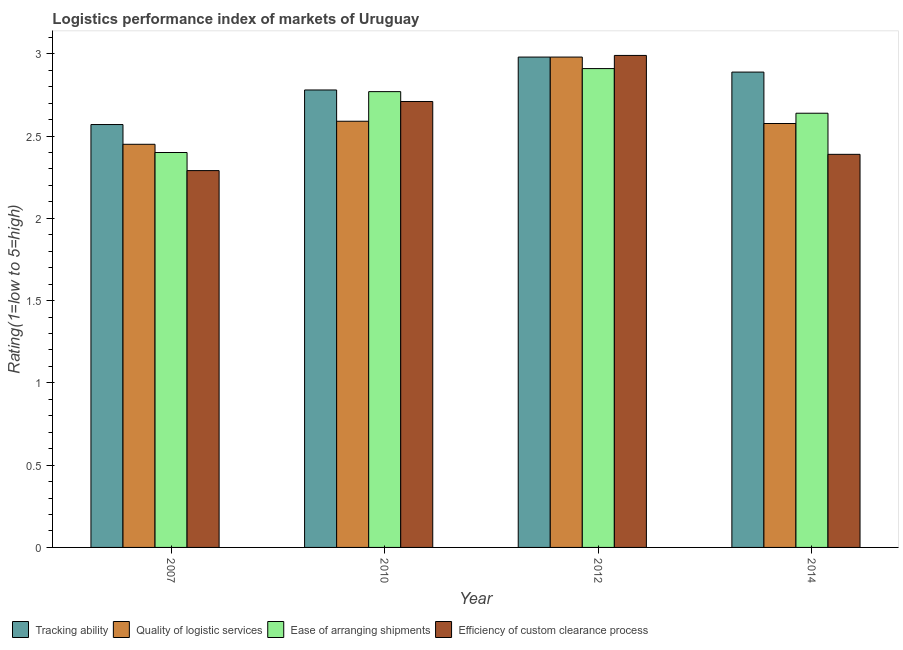How many different coloured bars are there?
Your answer should be compact. 4. How many groups of bars are there?
Ensure brevity in your answer.  4. Are the number of bars on each tick of the X-axis equal?
Your response must be concise. Yes. How many bars are there on the 4th tick from the left?
Your answer should be very brief. 4. How many bars are there on the 1st tick from the right?
Make the answer very short. 4. What is the lpi rating of ease of arranging shipments in 2014?
Offer a very short reply. 2.64. Across all years, what is the maximum lpi rating of efficiency of custom clearance process?
Give a very brief answer. 2.99. Across all years, what is the minimum lpi rating of tracking ability?
Make the answer very short. 2.57. What is the total lpi rating of efficiency of custom clearance process in the graph?
Provide a succinct answer. 10.38. What is the difference between the lpi rating of tracking ability in 2012 and that in 2014?
Provide a short and direct response. 0.09. What is the difference between the lpi rating of tracking ability in 2014 and the lpi rating of quality of logistic services in 2010?
Keep it short and to the point. 0.11. What is the average lpi rating of tracking ability per year?
Your response must be concise. 2.8. In how many years, is the lpi rating of efficiency of custom clearance process greater than 1.3?
Offer a very short reply. 4. What is the ratio of the lpi rating of ease of arranging shipments in 2010 to that in 2012?
Your answer should be very brief. 0.95. Is the lpi rating of efficiency of custom clearance process in 2007 less than that in 2012?
Give a very brief answer. Yes. Is the difference between the lpi rating of ease of arranging shipments in 2007 and 2010 greater than the difference between the lpi rating of quality of logistic services in 2007 and 2010?
Offer a very short reply. No. What is the difference between the highest and the second highest lpi rating of ease of arranging shipments?
Give a very brief answer. 0.14. What is the difference between the highest and the lowest lpi rating of quality of logistic services?
Keep it short and to the point. 0.53. In how many years, is the lpi rating of tracking ability greater than the average lpi rating of tracking ability taken over all years?
Provide a short and direct response. 2. What does the 2nd bar from the left in 2012 represents?
Provide a short and direct response. Quality of logistic services. What does the 2nd bar from the right in 2012 represents?
Offer a very short reply. Ease of arranging shipments. How many bars are there?
Your answer should be compact. 16. What is the difference between two consecutive major ticks on the Y-axis?
Your answer should be compact. 0.5. Are the values on the major ticks of Y-axis written in scientific E-notation?
Provide a short and direct response. No. Does the graph contain grids?
Ensure brevity in your answer.  No. How are the legend labels stacked?
Offer a terse response. Horizontal. What is the title of the graph?
Make the answer very short. Logistics performance index of markets of Uruguay. Does "European Union" appear as one of the legend labels in the graph?
Offer a very short reply. No. What is the label or title of the Y-axis?
Provide a short and direct response. Rating(1=low to 5=high). What is the Rating(1=low to 5=high) in Tracking ability in 2007?
Ensure brevity in your answer.  2.57. What is the Rating(1=low to 5=high) of Quality of logistic services in 2007?
Your answer should be compact. 2.45. What is the Rating(1=low to 5=high) in Ease of arranging shipments in 2007?
Your answer should be compact. 2.4. What is the Rating(1=low to 5=high) in Efficiency of custom clearance process in 2007?
Give a very brief answer. 2.29. What is the Rating(1=low to 5=high) in Tracking ability in 2010?
Give a very brief answer. 2.78. What is the Rating(1=low to 5=high) of Quality of logistic services in 2010?
Provide a short and direct response. 2.59. What is the Rating(1=low to 5=high) in Ease of arranging shipments in 2010?
Keep it short and to the point. 2.77. What is the Rating(1=low to 5=high) in Efficiency of custom clearance process in 2010?
Keep it short and to the point. 2.71. What is the Rating(1=low to 5=high) in Tracking ability in 2012?
Keep it short and to the point. 2.98. What is the Rating(1=low to 5=high) in Quality of logistic services in 2012?
Keep it short and to the point. 2.98. What is the Rating(1=low to 5=high) in Ease of arranging shipments in 2012?
Give a very brief answer. 2.91. What is the Rating(1=low to 5=high) in Efficiency of custom clearance process in 2012?
Give a very brief answer. 2.99. What is the Rating(1=low to 5=high) of Tracking ability in 2014?
Provide a short and direct response. 2.89. What is the Rating(1=low to 5=high) in Quality of logistic services in 2014?
Keep it short and to the point. 2.58. What is the Rating(1=low to 5=high) of Ease of arranging shipments in 2014?
Provide a short and direct response. 2.64. What is the Rating(1=low to 5=high) of Efficiency of custom clearance process in 2014?
Your answer should be compact. 2.39. Across all years, what is the maximum Rating(1=low to 5=high) in Tracking ability?
Your answer should be compact. 2.98. Across all years, what is the maximum Rating(1=low to 5=high) of Quality of logistic services?
Your response must be concise. 2.98. Across all years, what is the maximum Rating(1=low to 5=high) of Ease of arranging shipments?
Offer a very short reply. 2.91. Across all years, what is the maximum Rating(1=low to 5=high) of Efficiency of custom clearance process?
Your answer should be compact. 2.99. Across all years, what is the minimum Rating(1=low to 5=high) in Tracking ability?
Your answer should be very brief. 2.57. Across all years, what is the minimum Rating(1=low to 5=high) in Quality of logistic services?
Your answer should be compact. 2.45. Across all years, what is the minimum Rating(1=low to 5=high) in Efficiency of custom clearance process?
Provide a succinct answer. 2.29. What is the total Rating(1=low to 5=high) of Tracking ability in the graph?
Offer a very short reply. 11.22. What is the total Rating(1=low to 5=high) in Quality of logistic services in the graph?
Ensure brevity in your answer.  10.6. What is the total Rating(1=low to 5=high) in Ease of arranging shipments in the graph?
Offer a terse response. 10.72. What is the total Rating(1=low to 5=high) in Efficiency of custom clearance process in the graph?
Provide a short and direct response. 10.38. What is the difference between the Rating(1=low to 5=high) of Tracking ability in 2007 and that in 2010?
Your response must be concise. -0.21. What is the difference between the Rating(1=low to 5=high) in Quality of logistic services in 2007 and that in 2010?
Make the answer very short. -0.14. What is the difference between the Rating(1=low to 5=high) in Ease of arranging shipments in 2007 and that in 2010?
Offer a very short reply. -0.37. What is the difference between the Rating(1=low to 5=high) of Efficiency of custom clearance process in 2007 and that in 2010?
Your response must be concise. -0.42. What is the difference between the Rating(1=low to 5=high) in Tracking ability in 2007 and that in 2012?
Give a very brief answer. -0.41. What is the difference between the Rating(1=low to 5=high) of Quality of logistic services in 2007 and that in 2012?
Your answer should be very brief. -0.53. What is the difference between the Rating(1=low to 5=high) in Ease of arranging shipments in 2007 and that in 2012?
Your answer should be very brief. -0.51. What is the difference between the Rating(1=low to 5=high) in Efficiency of custom clearance process in 2007 and that in 2012?
Provide a short and direct response. -0.7. What is the difference between the Rating(1=low to 5=high) in Tracking ability in 2007 and that in 2014?
Your answer should be very brief. -0.32. What is the difference between the Rating(1=low to 5=high) in Quality of logistic services in 2007 and that in 2014?
Keep it short and to the point. -0.13. What is the difference between the Rating(1=low to 5=high) in Ease of arranging shipments in 2007 and that in 2014?
Give a very brief answer. -0.24. What is the difference between the Rating(1=low to 5=high) in Efficiency of custom clearance process in 2007 and that in 2014?
Your answer should be very brief. -0.1. What is the difference between the Rating(1=low to 5=high) of Quality of logistic services in 2010 and that in 2012?
Offer a terse response. -0.39. What is the difference between the Rating(1=low to 5=high) in Ease of arranging shipments in 2010 and that in 2012?
Keep it short and to the point. -0.14. What is the difference between the Rating(1=low to 5=high) in Efficiency of custom clearance process in 2010 and that in 2012?
Provide a succinct answer. -0.28. What is the difference between the Rating(1=low to 5=high) in Tracking ability in 2010 and that in 2014?
Ensure brevity in your answer.  -0.11. What is the difference between the Rating(1=low to 5=high) of Quality of logistic services in 2010 and that in 2014?
Make the answer very short. 0.01. What is the difference between the Rating(1=low to 5=high) in Ease of arranging shipments in 2010 and that in 2014?
Give a very brief answer. 0.13. What is the difference between the Rating(1=low to 5=high) in Efficiency of custom clearance process in 2010 and that in 2014?
Offer a terse response. 0.32. What is the difference between the Rating(1=low to 5=high) in Tracking ability in 2012 and that in 2014?
Provide a short and direct response. 0.09. What is the difference between the Rating(1=low to 5=high) in Quality of logistic services in 2012 and that in 2014?
Make the answer very short. 0.4. What is the difference between the Rating(1=low to 5=high) of Ease of arranging shipments in 2012 and that in 2014?
Ensure brevity in your answer.  0.27. What is the difference between the Rating(1=low to 5=high) in Efficiency of custom clearance process in 2012 and that in 2014?
Provide a succinct answer. 0.6. What is the difference between the Rating(1=low to 5=high) in Tracking ability in 2007 and the Rating(1=low to 5=high) in Quality of logistic services in 2010?
Keep it short and to the point. -0.02. What is the difference between the Rating(1=low to 5=high) of Tracking ability in 2007 and the Rating(1=low to 5=high) of Efficiency of custom clearance process in 2010?
Ensure brevity in your answer.  -0.14. What is the difference between the Rating(1=low to 5=high) of Quality of logistic services in 2007 and the Rating(1=low to 5=high) of Ease of arranging shipments in 2010?
Provide a short and direct response. -0.32. What is the difference between the Rating(1=low to 5=high) in Quality of logistic services in 2007 and the Rating(1=low to 5=high) in Efficiency of custom clearance process in 2010?
Ensure brevity in your answer.  -0.26. What is the difference between the Rating(1=low to 5=high) in Ease of arranging shipments in 2007 and the Rating(1=low to 5=high) in Efficiency of custom clearance process in 2010?
Ensure brevity in your answer.  -0.31. What is the difference between the Rating(1=low to 5=high) of Tracking ability in 2007 and the Rating(1=low to 5=high) of Quality of logistic services in 2012?
Provide a succinct answer. -0.41. What is the difference between the Rating(1=low to 5=high) of Tracking ability in 2007 and the Rating(1=low to 5=high) of Ease of arranging shipments in 2012?
Keep it short and to the point. -0.34. What is the difference between the Rating(1=low to 5=high) in Tracking ability in 2007 and the Rating(1=low to 5=high) in Efficiency of custom clearance process in 2012?
Offer a very short reply. -0.42. What is the difference between the Rating(1=low to 5=high) of Quality of logistic services in 2007 and the Rating(1=low to 5=high) of Ease of arranging shipments in 2012?
Ensure brevity in your answer.  -0.46. What is the difference between the Rating(1=low to 5=high) in Quality of logistic services in 2007 and the Rating(1=low to 5=high) in Efficiency of custom clearance process in 2012?
Your answer should be very brief. -0.54. What is the difference between the Rating(1=low to 5=high) in Ease of arranging shipments in 2007 and the Rating(1=low to 5=high) in Efficiency of custom clearance process in 2012?
Your response must be concise. -0.59. What is the difference between the Rating(1=low to 5=high) in Tracking ability in 2007 and the Rating(1=low to 5=high) in Quality of logistic services in 2014?
Offer a very short reply. -0.01. What is the difference between the Rating(1=low to 5=high) in Tracking ability in 2007 and the Rating(1=low to 5=high) in Ease of arranging shipments in 2014?
Keep it short and to the point. -0.07. What is the difference between the Rating(1=low to 5=high) in Tracking ability in 2007 and the Rating(1=low to 5=high) in Efficiency of custom clearance process in 2014?
Your answer should be very brief. 0.18. What is the difference between the Rating(1=low to 5=high) of Quality of logistic services in 2007 and the Rating(1=low to 5=high) of Ease of arranging shipments in 2014?
Ensure brevity in your answer.  -0.19. What is the difference between the Rating(1=low to 5=high) in Quality of logistic services in 2007 and the Rating(1=low to 5=high) in Efficiency of custom clearance process in 2014?
Your answer should be compact. 0.06. What is the difference between the Rating(1=low to 5=high) of Ease of arranging shipments in 2007 and the Rating(1=low to 5=high) of Efficiency of custom clearance process in 2014?
Your answer should be compact. 0.01. What is the difference between the Rating(1=low to 5=high) in Tracking ability in 2010 and the Rating(1=low to 5=high) in Ease of arranging shipments in 2012?
Your response must be concise. -0.13. What is the difference between the Rating(1=low to 5=high) in Tracking ability in 2010 and the Rating(1=low to 5=high) in Efficiency of custom clearance process in 2012?
Your answer should be compact. -0.21. What is the difference between the Rating(1=low to 5=high) of Quality of logistic services in 2010 and the Rating(1=low to 5=high) of Ease of arranging shipments in 2012?
Your answer should be very brief. -0.32. What is the difference between the Rating(1=low to 5=high) in Quality of logistic services in 2010 and the Rating(1=low to 5=high) in Efficiency of custom clearance process in 2012?
Provide a short and direct response. -0.4. What is the difference between the Rating(1=low to 5=high) of Ease of arranging shipments in 2010 and the Rating(1=low to 5=high) of Efficiency of custom clearance process in 2012?
Offer a very short reply. -0.22. What is the difference between the Rating(1=low to 5=high) in Tracking ability in 2010 and the Rating(1=low to 5=high) in Quality of logistic services in 2014?
Provide a succinct answer. 0.2. What is the difference between the Rating(1=low to 5=high) in Tracking ability in 2010 and the Rating(1=low to 5=high) in Ease of arranging shipments in 2014?
Offer a terse response. 0.14. What is the difference between the Rating(1=low to 5=high) in Tracking ability in 2010 and the Rating(1=low to 5=high) in Efficiency of custom clearance process in 2014?
Your answer should be compact. 0.39. What is the difference between the Rating(1=low to 5=high) of Quality of logistic services in 2010 and the Rating(1=low to 5=high) of Ease of arranging shipments in 2014?
Ensure brevity in your answer.  -0.05. What is the difference between the Rating(1=low to 5=high) in Quality of logistic services in 2010 and the Rating(1=low to 5=high) in Efficiency of custom clearance process in 2014?
Your answer should be compact. 0.2. What is the difference between the Rating(1=low to 5=high) in Ease of arranging shipments in 2010 and the Rating(1=low to 5=high) in Efficiency of custom clearance process in 2014?
Ensure brevity in your answer.  0.38. What is the difference between the Rating(1=low to 5=high) in Tracking ability in 2012 and the Rating(1=low to 5=high) in Quality of logistic services in 2014?
Make the answer very short. 0.4. What is the difference between the Rating(1=low to 5=high) in Tracking ability in 2012 and the Rating(1=low to 5=high) in Ease of arranging shipments in 2014?
Give a very brief answer. 0.34. What is the difference between the Rating(1=low to 5=high) in Tracking ability in 2012 and the Rating(1=low to 5=high) in Efficiency of custom clearance process in 2014?
Provide a short and direct response. 0.59. What is the difference between the Rating(1=low to 5=high) in Quality of logistic services in 2012 and the Rating(1=low to 5=high) in Ease of arranging shipments in 2014?
Your response must be concise. 0.34. What is the difference between the Rating(1=low to 5=high) in Quality of logistic services in 2012 and the Rating(1=low to 5=high) in Efficiency of custom clearance process in 2014?
Provide a short and direct response. 0.59. What is the difference between the Rating(1=low to 5=high) in Ease of arranging shipments in 2012 and the Rating(1=low to 5=high) in Efficiency of custom clearance process in 2014?
Keep it short and to the point. 0.52. What is the average Rating(1=low to 5=high) in Tracking ability per year?
Provide a succinct answer. 2.8. What is the average Rating(1=low to 5=high) of Quality of logistic services per year?
Provide a short and direct response. 2.65. What is the average Rating(1=low to 5=high) in Ease of arranging shipments per year?
Your answer should be very brief. 2.68. What is the average Rating(1=low to 5=high) in Efficiency of custom clearance process per year?
Your answer should be compact. 2.59. In the year 2007, what is the difference between the Rating(1=low to 5=high) in Tracking ability and Rating(1=low to 5=high) in Quality of logistic services?
Provide a succinct answer. 0.12. In the year 2007, what is the difference between the Rating(1=low to 5=high) of Tracking ability and Rating(1=low to 5=high) of Ease of arranging shipments?
Offer a very short reply. 0.17. In the year 2007, what is the difference between the Rating(1=low to 5=high) of Tracking ability and Rating(1=low to 5=high) of Efficiency of custom clearance process?
Your response must be concise. 0.28. In the year 2007, what is the difference between the Rating(1=low to 5=high) in Quality of logistic services and Rating(1=low to 5=high) in Ease of arranging shipments?
Keep it short and to the point. 0.05. In the year 2007, what is the difference between the Rating(1=low to 5=high) of Quality of logistic services and Rating(1=low to 5=high) of Efficiency of custom clearance process?
Make the answer very short. 0.16. In the year 2007, what is the difference between the Rating(1=low to 5=high) of Ease of arranging shipments and Rating(1=low to 5=high) of Efficiency of custom clearance process?
Your answer should be compact. 0.11. In the year 2010, what is the difference between the Rating(1=low to 5=high) of Tracking ability and Rating(1=low to 5=high) of Quality of logistic services?
Keep it short and to the point. 0.19. In the year 2010, what is the difference between the Rating(1=low to 5=high) of Tracking ability and Rating(1=low to 5=high) of Ease of arranging shipments?
Provide a succinct answer. 0.01. In the year 2010, what is the difference between the Rating(1=low to 5=high) in Tracking ability and Rating(1=low to 5=high) in Efficiency of custom clearance process?
Offer a terse response. 0.07. In the year 2010, what is the difference between the Rating(1=low to 5=high) of Quality of logistic services and Rating(1=low to 5=high) of Ease of arranging shipments?
Offer a very short reply. -0.18. In the year 2010, what is the difference between the Rating(1=low to 5=high) of Quality of logistic services and Rating(1=low to 5=high) of Efficiency of custom clearance process?
Offer a very short reply. -0.12. In the year 2012, what is the difference between the Rating(1=low to 5=high) in Tracking ability and Rating(1=low to 5=high) in Ease of arranging shipments?
Give a very brief answer. 0.07. In the year 2012, what is the difference between the Rating(1=low to 5=high) in Tracking ability and Rating(1=low to 5=high) in Efficiency of custom clearance process?
Your answer should be very brief. -0.01. In the year 2012, what is the difference between the Rating(1=low to 5=high) of Quality of logistic services and Rating(1=low to 5=high) of Ease of arranging shipments?
Make the answer very short. 0.07. In the year 2012, what is the difference between the Rating(1=low to 5=high) in Quality of logistic services and Rating(1=low to 5=high) in Efficiency of custom clearance process?
Keep it short and to the point. -0.01. In the year 2012, what is the difference between the Rating(1=low to 5=high) in Ease of arranging shipments and Rating(1=low to 5=high) in Efficiency of custom clearance process?
Ensure brevity in your answer.  -0.08. In the year 2014, what is the difference between the Rating(1=low to 5=high) in Tracking ability and Rating(1=low to 5=high) in Quality of logistic services?
Ensure brevity in your answer.  0.31. In the year 2014, what is the difference between the Rating(1=low to 5=high) of Tracking ability and Rating(1=low to 5=high) of Efficiency of custom clearance process?
Provide a succinct answer. 0.5. In the year 2014, what is the difference between the Rating(1=low to 5=high) of Quality of logistic services and Rating(1=low to 5=high) of Ease of arranging shipments?
Give a very brief answer. -0.06. In the year 2014, what is the difference between the Rating(1=low to 5=high) in Quality of logistic services and Rating(1=low to 5=high) in Efficiency of custom clearance process?
Ensure brevity in your answer.  0.19. In the year 2014, what is the difference between the Rating(1=low to 5=high) of Ease of arranging shipments and Rating(1=low to 5=high) of Efficiency of custom clearance process?
Your answer should be compact. 0.25. What is the ratio of the Rating(1=low to 5=high) of Tracking ability in 2007 to that in 2010?
Keep it short and to the point. 0.92. What is the ratio of the Rating(1=low to 5=high) in Quality of logistic services in 2007 to that in 2010?
Offer a terse response. 0.95. What is the ratio of the Rating(1=low to 5=high) in Ease of arranging shipments in 2007 to that in 2010?
Your response must be concise. 0.87. What is the ratio of the Rating(1=low to 5=high) in Efficiency of custom clearance process in 2007 to that in 2010?
Provide a succinct answer. 0.84. What is the ratio of the Rating(1=low to 5=high) in Tracking ability in 2007 to that in 2012?
Your answer should be compact. 0.86. What is the ratio of the Rating(1=low to 5=high) of Quality of logistic services in 2007 to that in 2012?
Your answer should be compact. 0.82. What is the ratio of the Rating(1=low to 5=high) of Ease of arranging shipments in 2007 to that in 2012?
Provide a succinct answer. 0.82. What is the ratio of the Rating(1=low to 5=high) of Efficiency of custom clearance process in 2007 to that in 2012?
Provide a succinct answer. 0.77. What is the ratio of the Rating(1=low to 5=high) of Tracking ability in 2007 to that in 2014?
Your answer should be compact. 0.89. What is the ratio of the Rating(1=low to 5=high) in Quality of logistic services in 2007 to that in 2014?
Your response must be concise. 0.95. What is the ratio of the Rating(1=low to 5=high) in Ease of arranging shipments in 2007 to that in 2014?
Give a very brief answer. 0.91. What is the ratio of the Rating(1=low to 5=high) of Efficiency of custom clearance process in 2007 to that in 2014?
Provide a short and direct response. 0.96. What is the ratio of the Rating(1=low to 5=high) in Tracking ability in 2010 to that in 2012?
Your answer should be compact. 0.93. What is the ratio of the Rating(1=low to 5=high) of Quality of logistic services in 2010 to that in 2012?
Offer a very short reply. 0.87. What is the ratio of the Rating(1=low to 5=high) of Ease of arranging shipments in 2010 to that in 2012?
Ensure brevity in your answer.  0.95. What is the ratio of the Rating(1=low to 5=high) in Efficiency of custom clearance process in 2010 to that in 2012?
Your answer should be very brief. 0.91. What is the ratio of the Rating(1=low to 5=high) in Tracking ability in 2010 to that in 2014?
Give a very brief answer. 0.96. What is the ratio of the Rating(1=low to 5=high) in Quality of logistic services in 2010 to that in 2014?
Offer a terse response. 1.01. What is the ratio of the Rating(1=low to 5=high) in Ease of arranging shipments in 2010 to that in 2014?
Your answer should be very brief. 1.05. What is the ratio of the Rating(1=low to 5=high) in Efficiency of custom clearance process in 2010 to that in 2014?
Ensure brevity in your answer.  1.13. What is the ratio of the Rating(1=low to 5=high) in Tracking ability in 2012 to that in 2014?
Ensure brevity in your answer.  1.03. What is the ratio of the Rating(1=low to 5=high) in Quality of logistic services in 2012 to that in 2014?
Give a very brief answer. 1.16. What is the ratio of the Rating(1=low to 5=high) in Ease of arranging shipments in 2012 to that in 2014?
Provide a succinct answer. 1.1. What is the ratio of the Rating(1=low to 5=high) of Efficiency of custom clearance process in 2012 to that in 2014?
Provide a short and direct response. 1.25. What is the difference between the highest and the second highest Rating(1=low to 5=high) of Tracking ability?
Your answer should be compact. 0.09. What is the difference between the highest and the second highest Rating(1=low to 5=high) in Quality of logistic services?
Ensure brevity in your answer.  0.39. What is the difference between the highest and the second highest Rating(1=low to 5=high) of Ease of arranging shipments?
Your answer should be very brief. 0.14. What is the difference between the highest and the second highest Rating(1=low to 5=high) in Efficiency of custom clearance process?
Your response must be concise. 0.28. What is the difference between the highest and the lowest Rating(1=low to 5=high) of Tracking ability?
Make the answer very short. 0.41. What is the difference between the highest and the lowest Rating(1=low to 5=high) of Quality of logistic services?
Your answer should be very brief. 0.53. What is the difference between the highest and the lowest Rating(1=low to 5=high) in Ease of arranging shipments?
Provide a succinct answer. 0.51. 